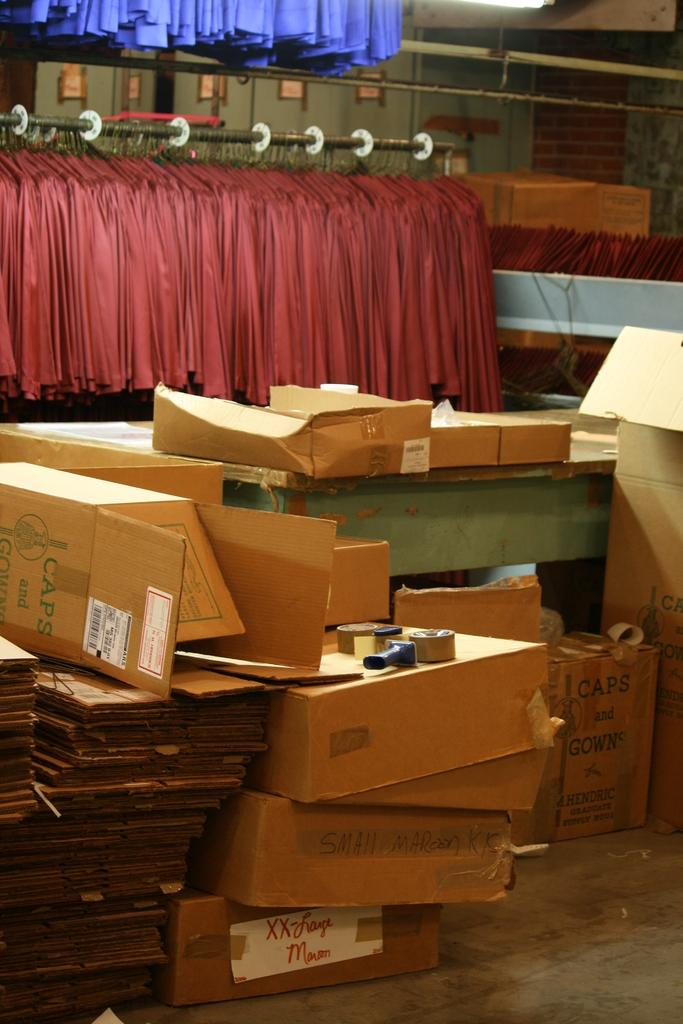What type of objects are present in large quantities in the image? There are many cardboard boxes in the image. What is the color of the cardboard boxes? The cardboard boxes are in brown color. What type of window treatment can be seen in the image? There are curtains in the background of the image. What colors are the curtains? The curtains are in maroon and purple color. What type of jar is visible on the cardboard boxes in the image? There is no jar present on the cardboard boxes in the image. 